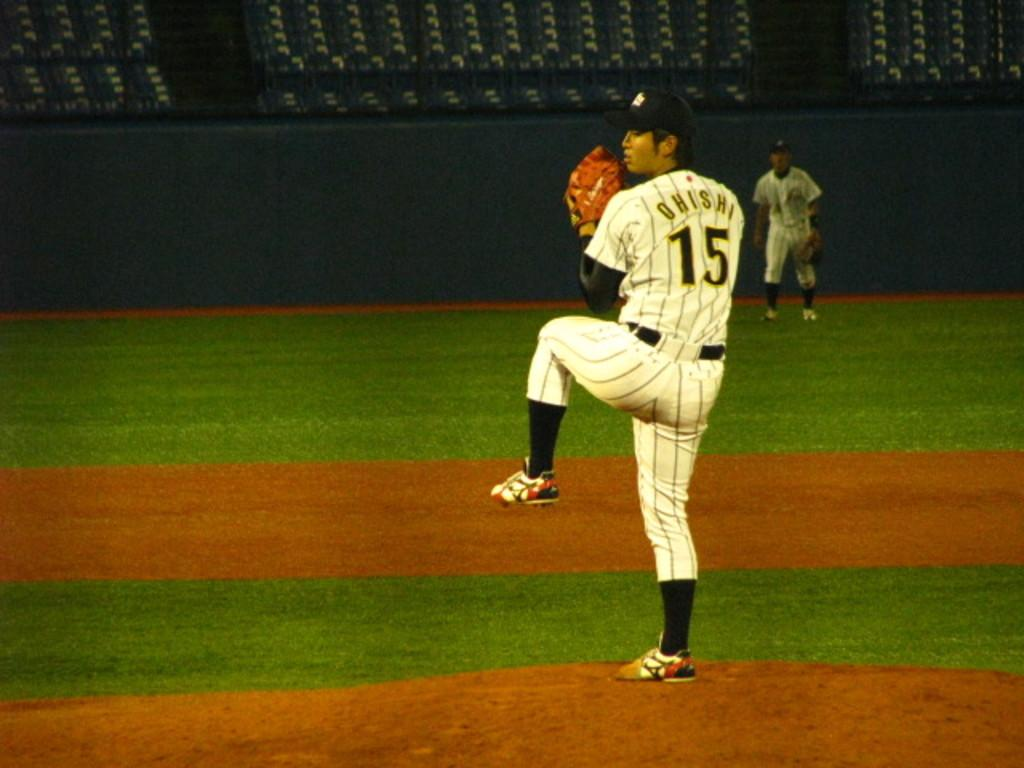<image>
Present a compact description of the photo's key features. A baseball player has the number fifteen on the back of his jersey. 